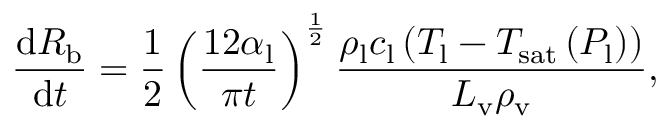Convert formula to latex. <formula><loc_0><loc_0><loc_500><loc_500>\frac { \mathrm d R _ { b } } { \mathrm d t } = \frac { 1 } { 2 } \left ( \frac { 1 2 \alpha _ { l } } { \pi t } \right ) ^ { \frac { 1 } { 2 } } \frac { \rho _ { l } c _ { l } \left ( T _ { l } - T _ { s a t } \left ( P _ { l } \right ) \right ) } { L _ { v } \rho _ { v } } ,</formula> 